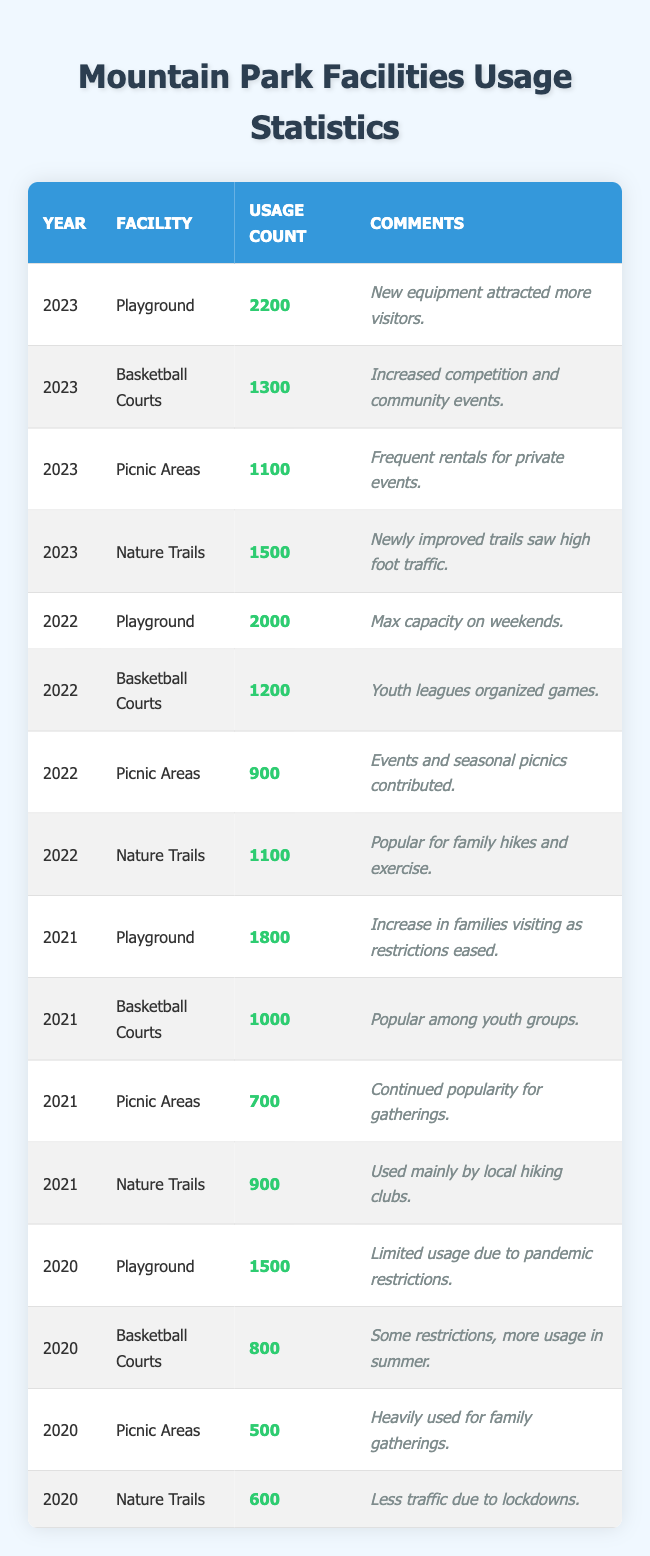What was the usage count for the Playground in 2023? In the row for the year 2023 under the Playground facility, the Usage Count is listed as 2200.
Answer: 2200 How many more times was the Playground used in 2022 compared to 2021? The usage count for the Playground in 2022 is 2000 and in 2021 it is 1800. The difference is 2000 - 1800 = 200.
Answer: 200 Did the usage count for Picnic Areas increase from 2021 to 2022? The usage count for Picnic Areas in 2021 is 700 and in 2022 it is 900. Since 900 is greater than 700, the usage count did increase.
Answer: Yes What was the total usage count for the Basketball Courts from 2020 to 2022? The usage counts for the Basketball Courts are 800 in 2020, 1000 in 2021, and 1200 in 2022. Adding these values gives 800 + 1000 + 1200 = 3000.
Answer: 3000 In which year did the Nature Trails have the highest usage count? Reviewing the rows for Nature Trails, 2023 records 1500, 2022 has 1100, 2021 has 900, and 2020 has 600. The highest value is 1500 in 2023.
Answer: 2023 What was the average usage for Nature Trails over the years 2020 to 2023? The usage counts for Nature Trails are 600 (2020), 900 (2021), 1100 (2022), and 1500 (2023). The sum is 600 + 900 + 1100 + 1500 = 3100. There are 4 years, so the average is 3100 / 4 = 775.
Answer: 775 Was the usage count for Picnic Areas in 2023 greater than the usage count for the same facility in 2020? The usage count for Picnic Areas in 2023 is 1100, while in 2020 it is 500. Since 1100 is greater than 500, the statement is true.
Answer: Yes Which facility had a significant increase in usage from 2020 to 2023? The Playground increased from 1500 in 2020 to 2200 in 2023, a rise of 700. The Basketball Courts also saw an increase from 800 to 1300. The Playground had a larger increase compared to other facilities.
Answer: Playground How many facilities were listed in the data for the year 2022? The data shows there are four facilities listed for the year 2022: Playground, Basketball Courts, Picnic Areas, and Nature Trails. So, that makes a total of four facilities.
Answer: 4 